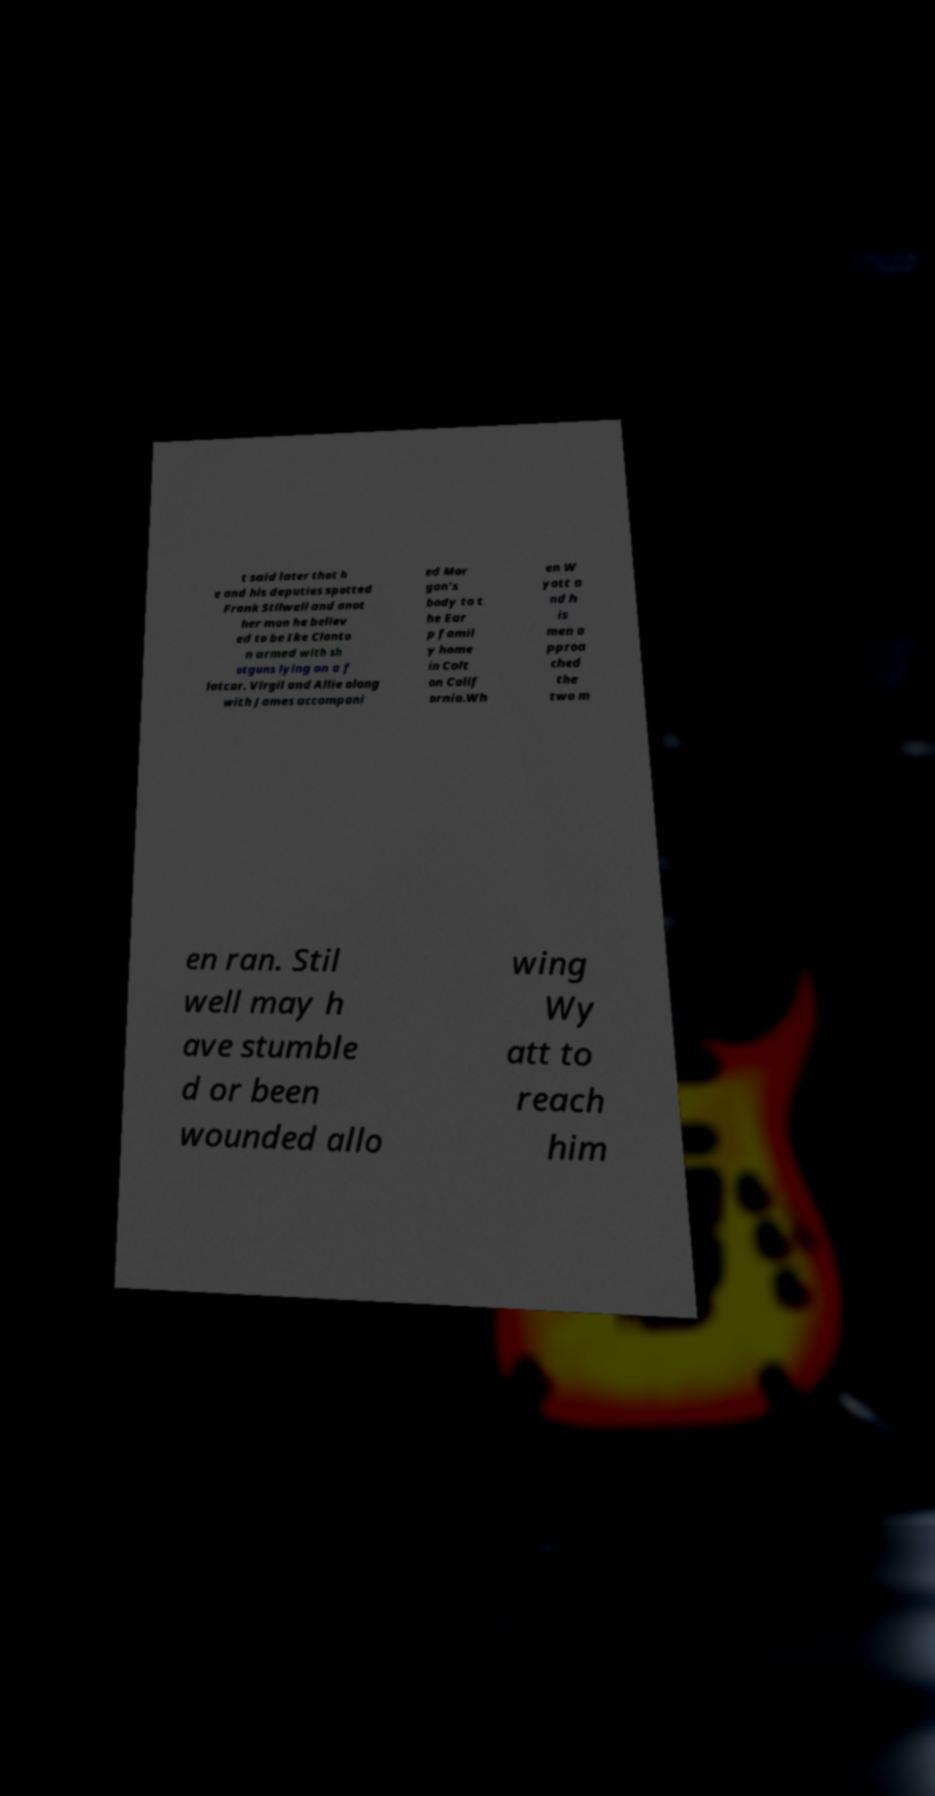Please read and relay the text visible in this image. What does it say? t said later that h e and his deputies spotted Frank Stilwell and anot her man he believ ed to be Ike Clanto n armed with sh otguns lying on a f latcar. Virgil and Allie along with James accompani ed Mor gan's body to t he Ear p famil y home in Colt on Calif ornia.Wh en W yatt a nd h is men a pproa ched the two m en ran. Stil well may h ave stumble d or been wounded allo wing Wy att to reach him 